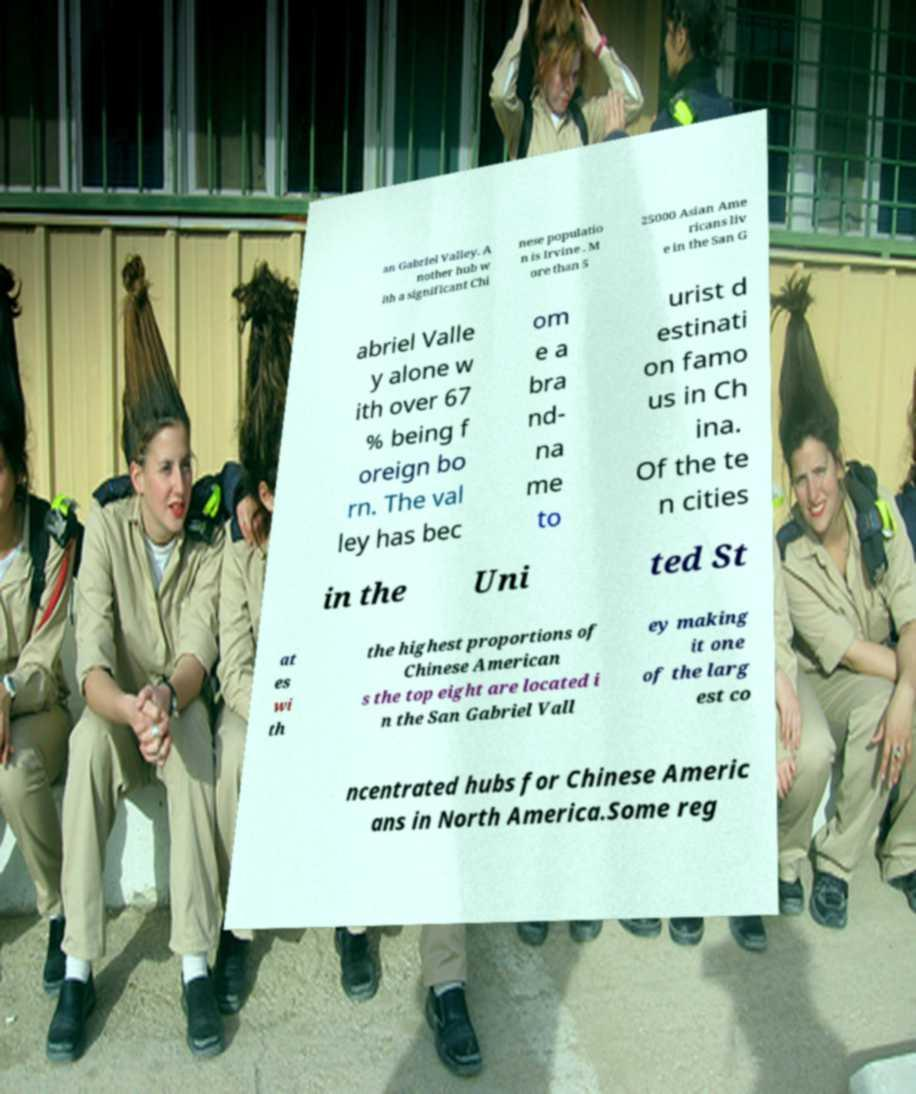What messages or text are displayed in this image? I need them in a readable, typed format. an Gabriel Valley. A nother hub w ith a significant Chi nese populatio n is Irvine . M ore than 5 25000 Asian Ame ricans liv e in the San G abriel Valle y alone w ith over 67 % being f oreign bo rn. The val ley has bec om e a bra nd- na me to urist d estinati on famo us in Ch ina. Of the te n cities in the Uni ted St at es wi th the highest proportions of Chinese American s the top eight are located i n the San Gabriel Vall ey making it one of the larg est co ncentrated hubs for Chinese Americ ans in North America.Some reg 